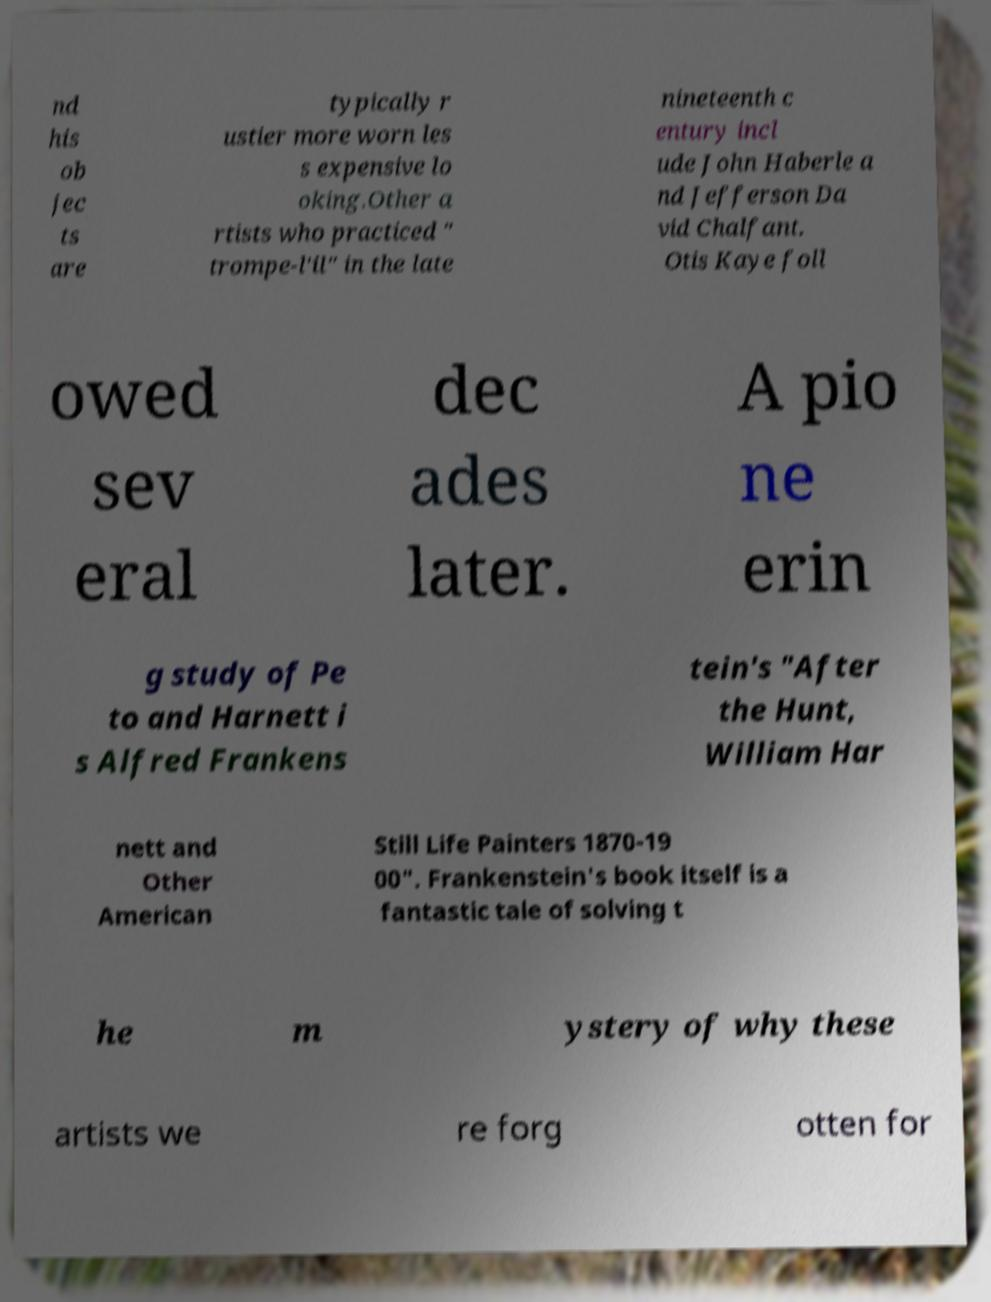Could you assist in decoding the text presented in this image and type it out clearly? nd his ob jec ts are typically r ustier more worn les s expensive lo oking.Other a rtists who practiced " trompe-l'il" in the late nineteenth c entury incl ude John Haberle a nd Jefferson Da vid Chalfant. Otis Kaye foll owed sev eral dec ades later. A pio ne erin g study of Pe to and Harnett i s Alfred Frankens tein's "After the Hunt, William Har nett and Other American Still Life Painters 1870-19 00". Frankenstein's book itself is a fantastic tale of solving t he m ystery of why these artists we re forg otten for 